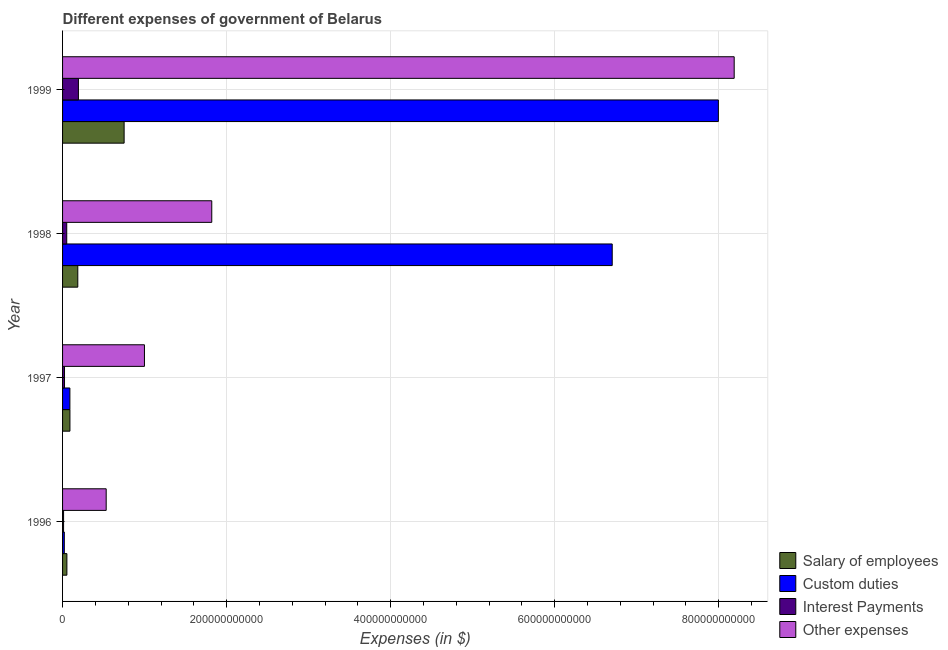How many different coloured bars are there?
Make the answer very short. 4. Are the number of bars per tick equal to the number of legend labels?
Offer a terse response. Yes. How many bars are there on the 1st tick from the top?
Your answer should be very brief. 4. What is the label of the 1st group of bars from the top?
Your response must be concise. 1999. What is the amount spent on other expenses in 1999?
Provide a succinct answer. 8.19e+11. Across all years, what is the maximum amount spent on interest payments?
Give a very brief answer. 1.93e+1. Across all years, what is the minimum amount spent on other expenses?
Give a very brief answer. 5.32e+1. What is the total amount spent on salary of employees in the graph?
Your answer should be very brief. 1.08e+11. What is the difference between the amount spent on custom duties in 1997 and that in 1998?
Your answer should be very brief. -6.61e+11. What is the difference between the amount spent on interest payments in 1997 and the amount spent on salary of employees in 1998?
Provide a succinct answer. -1.62e+1. What is the average amount spent on salary of employees per year?
Ensure brevity in your answer.  2.70e+1. In the year 1999, what is the difference between the amount spent on custom duties and amount spent on interest payments?
Make the answer very short. 7.80e+11. What is the ratio of the amount spent on custom duties in 1998 to that in 1999?
Offer a terse response. 0.84. Is the amount spent on custom duties in 1996 less than that in 1998?
Provide a succinct answer. Yes. What is the difference between the highest and the second highest amount spent on custom duties?
Your answer should be compact. 1.29e+11. What is the difference between the highest and the lowest amount spent on salary of employees?
Your answer should be compact. 6.98e+1. In how many years, is the amount spent on other expenses greater than the average amount spent on other expenses taken over all years?
Make the answer very short. 1. Is it the case that in every year, the sum of the amount spent on salary of employees and amount spent on custom duties is greater than the sum of amount spent on interest payments and amount spent on other expenses?
Your answer should be very brief. Yes. What does the 3rd bar from the top in 1996 represents?
Your answer should be compact. Custom duties. What does the 1st bar from the bottom in 1999 represents?
Your response must be concise. Salary of employees. How many years are there in the graph?
Ensure brevity in your answer.  4. What is the difference between two consecutive major ticks on the X-axis?
Make the answer very short. 2.00e+11. Does the graph contain grids?
Provide a short and direct response. Yes. How are the legend labels stacked?
Your response must be concise. Vertical. What is the title of the graph?
Ensure brevity in your answer.  Different expenses of government of Belarus. What is the label or title of the X-axis?
Give a very brief answer. Expenses (in $). What is the Expenses (in $) of Salary of employees in 1996?
Provide a succinct answer. 5.28e+09. What is the Expenses (in $) of Custom duties in 1996?
Offer a very short reply. 2.12e+09. What is the Expenses (in $) of Interest Payments in 1996?
Keep it short and to the point. 1.23e+09. What is the Expenses (in $) in Other expenses in 1996?
Make the answer very short. 5.32e+1. What is the Expenses (in $) in Salary of employees in 1997?
Keep it short and to the point. 8.98e+09. What is the Expenses (in $) of Custom duties in 1997?
Keep it short and to the point. 8.93e+09. What is the Expenses (in $) in Interest Payments in 1997?
Offer a terse response. 2.37e+09. What is the Expenses (in $) in Other expenses in 1997?
Your answer should be very brief. 9.98e+1. What is the Expenses (in $) in Salary of employees in 1998?
Your response must be concise. 1.86e+1. What is the Expenses (in $) in Custom duties in 1998?
Keep it short and to the point. 6.70e+11. What is the Expenses (in $) of Interest Payments in 1998?
Provide a succinct answer. 5.09e+09. What is the Expenses (in $) of Other expenses in 1998?
Offer a very short reply. 1.82e+11. What is the Expenses (in $) of Salary of employees in 1999?
Your answer should be compact. 7.50e+1. What is the Expenses (in $) in Custom duties in 1999?
Give a very brief answer. 8.00e+11. What is the Expenses (in $) in Interest Payments in 1999?
Your answer should be very brief. 1.93e+1. What is the Expenses (in $) of Other expenses in 1999?
Ensure brevity in your answer.  8.19e+11. Across all years, what is the maximum Expenses (in $) of Salary of employees?
Your answer should be compact. 7.50e+1. Across all years, what is the maximum Expenses (in $) in Custom duties?
Give a very brief answer. 8.00e+11. Across all years, what is the maximum Expenses (in $) of Interest Payments?
Offer a terse response. 1.93e+1. Across all years, what is the maximum Expenses (in $) in Other expenses?
Provide a short and direct response. 8.19e+11. Across all years, what is the minimum Expenses (in $) in Salary of employees?
Offer a terse response. 5.28e+09. Across all years, what is the minimum Expenses (in $) in Custom duties?
Ensure brevity in your answer.  2.12e+09. Across all years, what is the minimum Expenses (in $) of Interest Payments?
Keep it short and to the point. 1.23e+09. Across all years, what is the minimum Expenses (in $) in Other expenses?
Provide a short and direct response. 5.32e+1. What is the total Expenses (in $) of Salary of employees in the graph?
Your answer should be compact. 1.08e+11. What is the total Expenses (in $) in Custom duties in the graph?
Keep it short and to the point. 1.48e+12. What is the total Expenses (in $) of Interest Payments in the graph?
Offer a terse response. 2.80e+1. What is the total Expenses (in $) of Other expenses in the graph?
Give a very brief answer. 1.15e+12. What is the difference between the Expenses (in $) in Salary of employees in 1996 and that in 1997?
Ensure brevity in your answer.  -3.70e+09. What is the difference between the Expenses (in $) in Custom duties in 1996 and that in 1997?
Your answer should be very brief. -6.81e+09. What is the difference between the Expenses (in $) of Interest Payments in 1996 and that in 1997?
Keep it short and to the point. -1.15e+09. What is the difference between the Expenses (in $) of Other expenses in 1996 and that in 1997?
Provide a short and direct response. -4.66e+1. What is the difference between the Expenses (in $) in Salary of employees in 1996 and that in 1998?
Ensure brevity in your answer.  -1.33e+1. What is the difference between the Expenses (in $) of Custom duties in 1996 and that in 1998?
Provide a short and direct response. -6.68e+11. What is the difference between the Expenses (in $) in Interest Payments in 1996 and that in 1998?
Offer a very short reply. -3.86e+09. What is the difference between the Expenses (in $) in Other expenses in 1996 and that in 1998?
Ensure brevity in your answer.  -1.29e+11. What is the difference between the Expenses (in $) in Salary of employees in 1996 and that in 1999?
Make the answer very short. -6.98e+1. What is the difference between the Expenses (in $) in Custom duties in 1996 and that in 1999?
Offer a very short reply. -7.97e+11. What is the difference between the Expenses (in $) of Interest Payments in 1996 and that in 1999?
Your response must be concise. -1.81e+1. What is the difference between the Expenses (in $) in Other expenses in 1996 and that in 1999?
Make the answer very short. -7.66e+11. What is the difference between the Expenses (in $) in Salary of employees in 1997 and that in 1998?
Provide a short and direct response. -9.59e+09. What is the difference between the Expenses (in $) in Custom duties in 1997 and that in 1998?
Your response must be concise. -6.61e+11. What is the difference between the Expenses (in $) in Interest Payments in 1997 and that in 1998?
Provide a succinct answer. -2.71e+09. What is the difference between the Expenses (in $) in Other expenses in 1997 and that in 1998?
Your answer should be compact. -8.21e+1. What is the difference between the Expenses (in $) of Salary of employees in 1997 and that in 1999?
Offer a very short reply. -6.61e+1. What is the difference between the Expenses (in $) of Custom duties in 1997 and that in 1999?
Provide a succinct answer. -7.91e+11. What is the difference between the Expenses (in $) of Interest Payments in 1997 and that in 1999?
Offer a terse response. -1.70e+1. What is the difference between the Expenses (in $) in Other expenses in 1997 and that in 1999?
Your answer should be compact. -7.19e+11. What is the difference between the Expenses (in $) in Salary of employees in 1998 and that in 1999?
Provide a succinct answer. -5.65e+1. What is the difference between the Expenses (in $) of Custom duties in 1998 and that in 1999?
Offer a very short reply. -1.29e+11. What is the difference between the Expenses (in $) of Interest Payments in 1998 and that in 1999?
Ensure brevity in your answer.  -1.42e+1. What is the difference between the Expenses (in $) in Other expenses in 1998 and that in 1999?
Your answer should be very brief. -6.37e+11. What is the difference between the Expenses (in $) of Salary of employees in 1996 and the Expenses (in $) of Custom duties in 1997?
Your response must be concise. -3.65e+09. What is the difference between the Expenses (in $) of Salary of employees in 1996 and the Expenses (in $) of Interest Payments in 1997?
Offer a very short reply. 2.91e+09. What is the difference between the Expenses (in $) of Salary of employees in 1996 and the Expenses (in $) of Other expenses in 1997?
Offer a very short reply. -9.45e+1. What is the difference between the Expenses (in $) of Custom duties in 1996 and the Expenses (in $) of Interest Payments in 1997?
Provide a succinct answer. -2.49e+08. What is the difference between the Expenses (in $) in Custom duties in 1996 and the Expenses (in $) in Other expenses in 1997?
Provide a succinct answer. -9.77e+1. What is the difference between the Expenses (in $) in Interest Payments in 1996 and the Expenses (in $) in Other expenses in 1997?
Provide a short and direct response. -9.86e+1. What is the difference between the Expenses (in $) of Salary of employees in 1996 and the Expenses (in $) of Custom duties in 1998?
Your answer should be very brief. -6.65e+11. What is the difference between the Expenses (in $) in Salary of employees in 1996 and the Expenses (in $) in Interest Payments in 1998?
Give a very brief answer. 1.95e+08. What is the difference between the Expenses (in $) of Salary of employees in 1996 and the Expenses (in $) of Other expenses in 1998?
Provide a succinct answer. -1.77e+11. What is the difference between the Expenses (in $) of Custom duties in 1996 and the Expenses (in $) of Interest Payments in 1998?
Make the answer very short. -2.96e+09. What is the difference between the Expenses (in $) in Custom duties in 1996 and the Expenses (in $) in Other expenses in 1998?
Ensure brevity in your answer.  -1.80e+11. What is the difference between the Expenses (in $) in Interest Payments in 1996 and the Expenses (in $) in Other expenses in 1998?
Provide a succinct answer. -1.81e+11. What is the difference between the Expenses (in $) in Salary of employees in 1996 and the Expenses (in $) in Custom duties in 1999?
Ensure brevity in your answer.  -7.94e+11. What is the difference between the Expenses (in $) of Salary of employees in 1996 and the Expenses (in $) of Interest Payments in 1999?
Your answer should be compact. -1.40e+1. What is the difference between the Expenses (in $) of Salary of employees in 1996 and the Expenses (in $) of Other expenses in 1999?
Your answer should be compact. -8.14e+11. What is the difference between the Expenses (in $) of Custom duties in 1996 and the Expenses (in $) of Interest Payments in 1999?
Your answer should be compact. -1.72e+1. What is the difference between the Expenses (in $) of Custom duties in 1996 and the Expenses (in $) of Other expenses in 1999?
Give a very brief answer. -8.17e+11. What is the difference between the Expenses (in $) in Interest Payments in 1996 and the Expenses (in $) in Other expenses in 1999?
Your response must be concise. -8.18e+11. What is the difference between the Expenses (in $) of Salary of employees in 1997 and the Expenses (in $) of Custom duties in 1998?
Give a very brief answer. -6.61e+11. What is the difference between the Expenses (in $) of Salary of employees in 1997 and the Expenses (in $) of Interest Payments in 1998?
Keep it short and to the point. 3.89e+09. What is the difference between the Expenses (in $) in Salary of employees in 1997 and the Expenses (in $) in Other expenses in 1998?
Offer a very short reply. -1.73e+11. What is the difference between the Expenses (in $) in Custom duties in 1997 and the Expenses (in $) in Interest Payments in 1998?
Ensure brevity in your answer.  3.85e+09. What is the difference between the Expenses (in $) in Custom duties in 1997 and the Expenses (in $) in Other expenses in 1998?
Your answer should be compact. -1.73e+11. What is the difference between the Expenses (in $) in Interest Payments in 1997 and the Expenses (in $) in Other expenses in 1998?
Give a very brief answer. -1.80e+11. What is the difference between the Expenses (in $) in Salary of employees in 1997 and the Expenses (in $) in Custom duties in 1999?
Keep it short and to the point. -7.91e+11. What is the difference between the Expenses (in $) of Salary of employees in 1997 and the Expenses (in $) of Interest Payments in 1999?
Offer a terse response. -1.03e+1. What is the difference between the Expenses (in $) of Salary of employees in 1997 and the Expenses (in $) of Other expenses in 1999?
Provide a short and direct response. -8.10e+11. What is the difference between the Expenses (in $) of Custom duties in 1997 and the Expenses (in $) of Interest Payments in 1999?
Your response must be concise. -1.04e+1. What is the difference between the Expenses (in $) of Custom duties in 1997 and the Expenses (in $) of Other expenses in 1999?
Ensure brevity in your answer.  -8.10e+11. What is the difference between the Expenses (in $) in Interest Payments in 1997 and the Expenses (in $) in Other expenses in 1999?
Make the answer very short. -8.16e+11. What is the difference between the Expenses (in $) of Salary of employees in 1998 and the Expenses (in $) of Custom duties in 1999?
Give a very brief answer. -7.81e+11. What is the difference between the Expenses (in $) of Salary of employees in 1998 and the Expenses (in $) of Interest Payments in 1999?
Ensure brevity in your answer.  -7.59e+08. What is the difference between the Expenses (in $) of Salary of employees in 1998 and the Expenses (in $) of Other expenses in 1999?
Keep it short and to the point. -8.00e+11. What is the difference between the Expenses (in $) in Custom duties in 1998 and the Expenses (in $) in Interest Payments in 1999?
Your answer should be very brief. 6.51e+11. What is the difference between the Expenses (in $) in Custom duties in 1998 and the Expenses (in $) in Other expenses in 1999?
Make the answer very short. -1.49e+11. What is the difference between the Expenses (in $) in Interest Payments in 1998 and the Expenses (in $) in Other expenses in 1999?
Your response must be concise. -8.14e+11. What is the average Expenses (in $) of Salary of employees per year?
Keep it short and to the point. 2.70e+1. What is the average Expenses (in $) in Custom duties per year?
Make the answer very short. 3.70e+11. What is the average Expenses (in $) of Interest Payments per year?
Offer a terse response. 7.00e+09. What is the average Expenses (in $) in Other expenses per year?
Your answer should be very brief. 2.88e+11. In the year 1996, what is the difference between the Expenses (in $) of Salary of employees and Expenses (in $) of Custom duties?
Your answer should be compact. 3.16e+09. In the year 1996, what is the difference between the Expenses (in $) of Salary of employees and Expenses (in $) of Interest Payments?
Provide a short and direct response. 4.06e+09. In the year 1996, what is the difference between the Expenses (in $) in Salary of employees and Expenses (in $) in Other expenses?
Your answer should be very brief. -4.79e+1. In the year 1996, what is the difference between the Expenses (in $) in Custom duties and Expenses (in $) in Interest Payments?
Keep it short and to the point. 8.98e+08. In the year 1996, what is the difference between the Expenses (in $) of Custom duties and Expenses (in $) of Other expenses?
Offer a very short reply. -5.11e+1. In the year 1996, what is the difference between the Expenses (in $) of Interest Payments and Expenses (in $) of Other expenses?
Keep it short and to the point. -5.20e+1. In the year 1997, what is the difference between the Expenses (in $) in Salary of employees and Expenses (in $) in Custom duties?
Keep it short and to the point. 4.52e+07. In the year 1997, what is the difference between the Expenses (in $) in Salary of employees and Expenses (in $) in Interest Payments?
Your answer should be compact. 6.61e+09. In the year 1997, what is the difference between the Expenses (in $) in Salary of employees and Expenses (in $) in Other expenses?
Provide a succinct answer. -9.09e+1. In the year 1997, what is the difference between the Expenses (in $) of Custom duties and Expenses (in $) of Interest Payments?
Your response must be concise. 6.56e+09. In the year 1997, what is the difference between the Expenses (in $) in Custom duties and Expenses (in $) in Other expenses?
Keep it short and to the point. -9.09e+1. In the year 1997, what is the difference between the Expenses (in $) of Interest Payments and Expenses (in $) of Other expenses?
Provide a short and direct response. -9.75e+1. In the year 1998, what is the difference between the Expenses (in $) in Salary of employees and Expenses (in $) in Custom duties?
Give a very brief answer. -6.52e+11. In the year 1998, what is the difference between the Expenses (in $) of Salary of employees and Expenses (in $) of Interest Payments?
Make the answer very short. 1.35e+1. In the year 1998, what is the difference between the Expenses (in $) of Salary of employees and Expenses (in $) of Other expenses?
Offer a terse response. -1.63e+11. In the year 1998, what is the difference between the Expenses (in $) in Custom duties and Expenses (in $) in Interest Payments?
Provide a succinct answer. 6.65e+11. In the year 1998, what is the difference between the Expenses (in $) in Custom duties and Expenses (in $) in Other expenses?
Your answer should be compact. 4.88e+11. In the year 1998, what is the difference between the Expenses (in $) in Interest Payments and Expenses (in $) in Other expenses?
Your answer should be compact. -1.77e+11. In the year 1999, what is the difference between the Expenses (in $) in Salary of employees and Expenses (in $) in Custom duties?
Provide a short and direct response. -7.24e+11. In the year 1999, what is the difference between the Expenses (in $) in Salary of employees and Expenses (in $) in Interest Payments?
Make the answer very short. 5.57e+1. In the year 1999, what is the difference between the Expenses (in $) in Salary of employees and Expenses (in $) in Other expenses?
Offer a terse response. -7.44e+11. In the year 1999, what is the difference between the Expenses (in $) of Custom duties and Expenses (in $) of Interest Payments?
Give a very brief answer. 7.80e+11. In the year 1999, what is the difference between the Expenses (in $) of Custom duties and Expenses (in $) of Other expenses?
Give a very brief answer. -1.93e+1. In the year 1999, what is the difference between the Expenses (in $) of Interest Payments and Expenses (in $) of Other expenses?
Give a very brief answer. -7.99e+11. What is the ratio of the Expenses (in $) of Salary of employees in 1996 to that in 1997?
Your response must be concise. 0.59. What is the ratio of the Expenses (in $) in Custom duties in 1996 to that in 1997?
Ensure brevity in your answer.  0.24. What is the ratio of the Expenses (in $) in Interest Payments in 1996 to that in 1997?
Your answer should be compact. 0.52. What is the ratio of the Expenses (in $) of Other expenses in 1996 to that in 1997?
Your response must be concise. 0.53. What is the ratio of the Expenses (in $) in Salary of employees in 1996 to that in 1998?
Keep it short and to the point. 0.28. What is the ratio of the Expenses (in $) in Custom duties in 1996 to that in 1998?
Provide a short and direct response. 0. What is the ratio of the Expenses (in $) of Interest Payments in 1996 to that in 1998?
Keep it short and to the point. 0.24. What is the ratio of the Expenses (in $) of Other expenses in 1996 to that in 1998?
Provide a short and direct response. 0.29. What is the ratio of the Expenses (in $) in Salary of employees in 1996 to that in 1999?
Your answer should be very brief. 0.07. What is the ratio of the Expenses (in $) of Custom duties in 1996 to that in 1999?
Your response must be concise. 0. What is the ratio of the Expenses (in $) of Interest Payments in 1996 to that in 1999?
Provide a short and direct response. 0.06. What is the ratio of the Expenses (in $) in Other expenses in 1996 to that in 1999?
Provide a succinct answer. 0.07. What is the ratio of the Expenses (in $) in Salary of employees in 1997 to that in 1998?
Provide a succinct answer. 0.48. What is the ratio of the Expenses (in $) in Custom duties in 1997 to that in 1998?
Provide a short and direct response. 0.01. What is the ratio of the Expenses (in $) in Interest Payments in 1997 to that in 1998?
Make the answer very short. 0.47. What is the ratio of the Expenses (in $) of Other expenses in 1997 to that in 1998?
Provide a succinct answer. 0.55. What is the ratio of the Expenses (in $) of Salary of employees in 1997 to that in 1999?
Your response must be concise. 0.12. What is the ratio of the Expenses (in $) in Custom duties in 1997 to that in 1999?
Offer a terse response. 0.01. What is the ratio of the Expenses (in $) in Interest Payments in 1997 to that in 1999?
Keep it short and to the point. 0.12. What is the ratio of the Expenses (in $) in Other expenses in 1997 to that in 1999?
Your answer should be compact. 0.12. What is the ratio of the Expenses (in $) in Salary of employees in 1998 to that in 1999?
Give a very brief answer. 0.25. What is the ratio of the Expenses (in $) of Custom duties in 1998 to that in 1999?
Your response must be concise. 0.84. What is the ratio of the Expenses (in $) of Interest Payments in 1998 to that in 1999?
Provide a short and direct response. 0.26. What is the ratio of the Expenses (in $) in Other expenses in 1998 to that in 1999?
Provide a succinct answer. 0.22. What is the difference between the highest and the second highest Expenses (in $) of Salary of employees?
Provide a succinct answer. 5.65e+1. What is the difference between the highest and the second highest Expenses (in $) of Custom duties?
Ensure brevity in your answer.  1.29e+11. What is the difference between the highest and the second highest Expenses (in $) in Interest Payments?
Offer a terse response. 1.42e+1. What is the difference between the highest and the second highest Expenses (in $) in Other expenses?
Give a very brief answer. 6.37e+11. What is the difference between the highest and the lowest Expenses (in $) in Salary of employees?
Provide a short and direct response. 6.98e+1. What is the difference between the highest and the lowest Expenses (in $) in Custom duties?
Provide a succinct answer. 7.97e+11. What is the difference between the highest and the lowest Expenses (in $) in Interest Payments?
Make the answer very short. 1.81e+1. What is the difference between the highest and the lowest Expenses (in $) in Other expenses?
Offer a very short reply. 7.66e+11. 